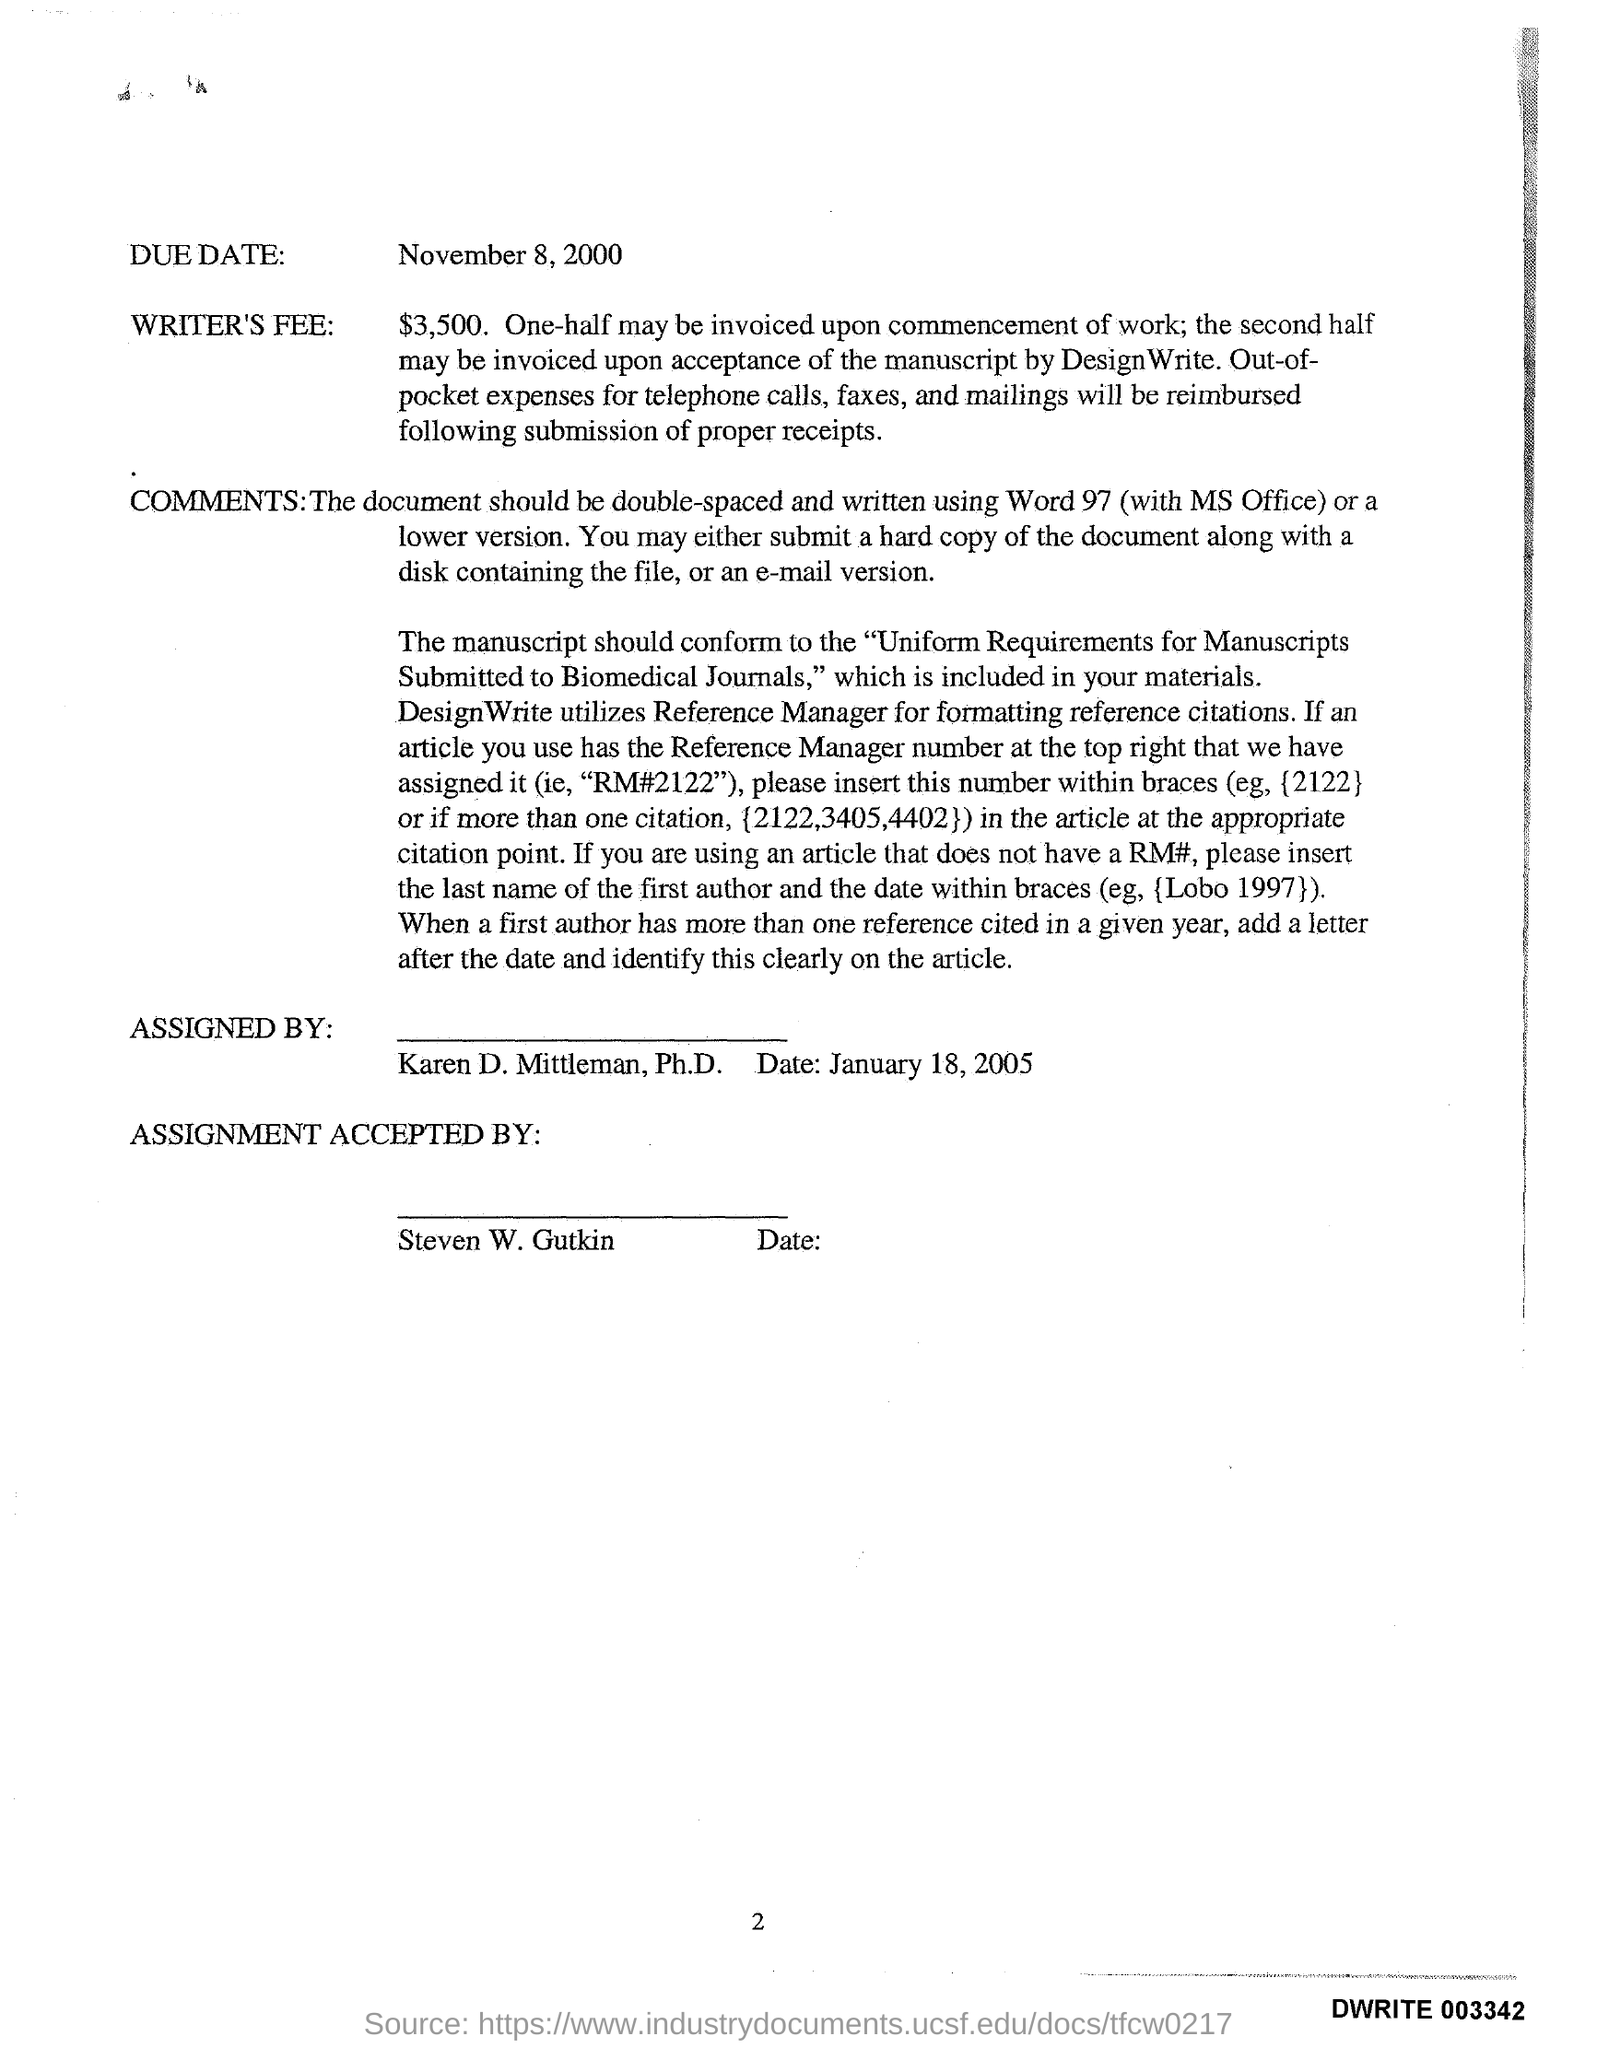List a handful of essential elements in this visual. The fee for a writer is $3,500. 